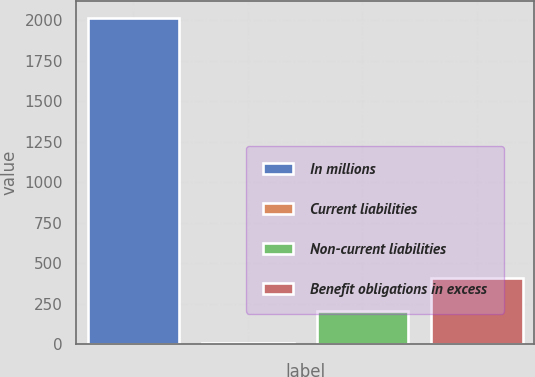<chart> <loc_0><loc_0><loc_500><loc_500><bar_chart><fcel>In millions<fcel>Current liabilities<fcel>Non-current liabilities<fcel>Benefit obligations in excess<nl><fcel>2016<fcel>4.4<fcel>205.56<fcel>406.72<nl></chart> 